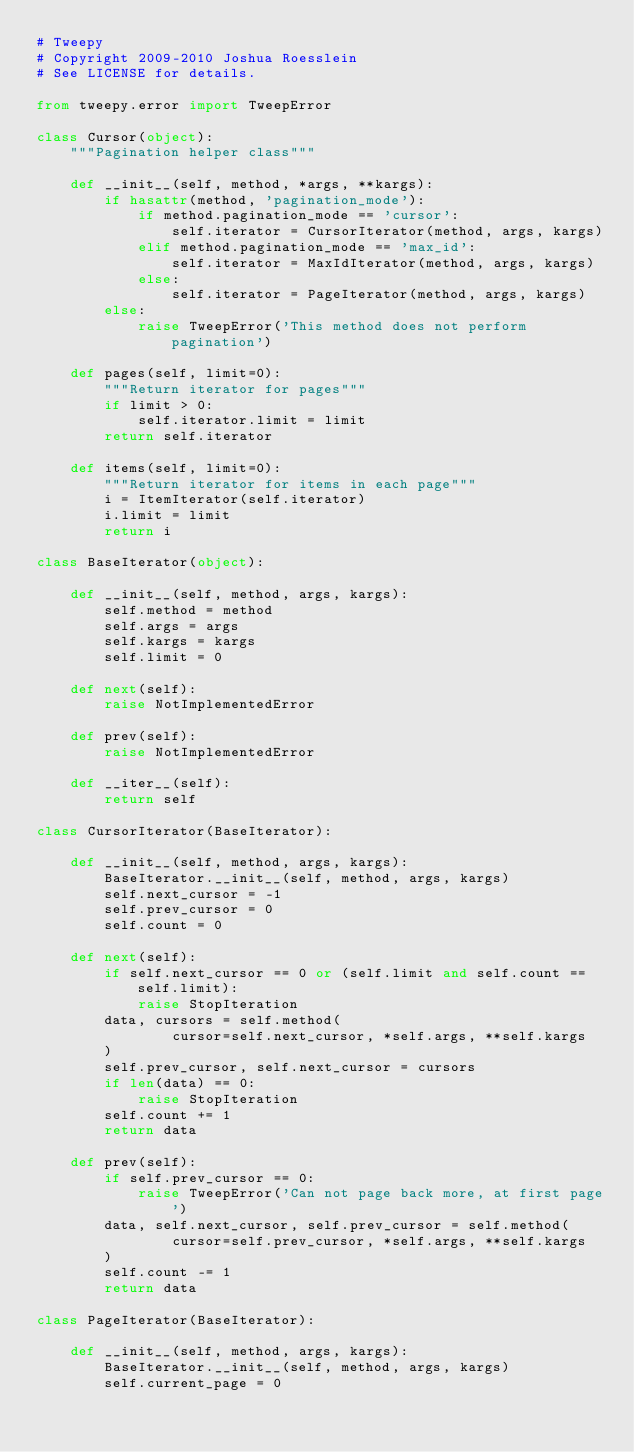Convert code to text. <code><loc_0><loc_0><loc_500><loc_500><_Python_># Tweepy
# Copyright 2009-2010 Joshua Roesslein
# See LICENSE for details.

from tweepy.error import TweepError

class Cursor(object):
    """Pagination helper class"""

    def __init__(self, method, *args, **kargs):
        if hasattr(method, 'pagination_mode'):
            if method.pagination_mode == 'cursor':
                self.iterator = CursorIterator(method, args, kargs)
            elif method.pagination_mode == 'max_id':
                self.iterator = MaxIdIterator(method, args, kargs)
            else:
                self.iterator = PageIterator(method, args, kargs)
        else:
            raise TweepError('This method does not perform pagination')

    def pages(self, limit=0):
        """Return iterator for pages"""
        if limit > 0:
            self.iterator.limit = limit
        return self.iterator

    def items(self, limit=0):
        """Return iterator for items in each page"""
        i = ItemIterator(self.iterator)
        i.limit = limit
        return i

class BaseIterator(object):

    def __init__(self, method, args, kargs):
        self.method = method
        self.args = args
        self.kargs = kargs
        self.limit = 0

    def next(self):
        raise NotImplementedError

    def prev(self):
        raise NotImplementedError

    def __iter__(self):
        return self

class CursorIterator(BaseIterator):

    def __init__(self, method, args, kargs):
        BaseIterator.__init__(self, method, args, kargs)
        self.next_cursor = -1
        self.prev_cursor = 0
        self.count = 0

    def next(self):
        if self.next_cursor == 0 or (self.limit and self.count == self.limit):
            raise StopIteration
        data, cursors = self.method(
                cursor=self.next_cursor, *self.args, **self.kargs
        )
        self.prev_cursor, self.next_cursor = cursors
        if len(data) == 0:
            raise StopIteration
        self.count += 1
        return data

    def prev(self):
        if self.prev_cursor == 0:
            raise TweepError('Can not page back more, at first page')
        data, self.next_cursor, self.prev_cursor = self.method(
                cursor=self.prev_cursor, *self.args, **self.kargs
        )
        self.count -= 1
        return data

class PageIterator(BaseIterator):

    def __init__(self, method, args, kargs):
        BaseIterator.__init__(self, method, args, kargs)
        self.current_page = 0
</code> 